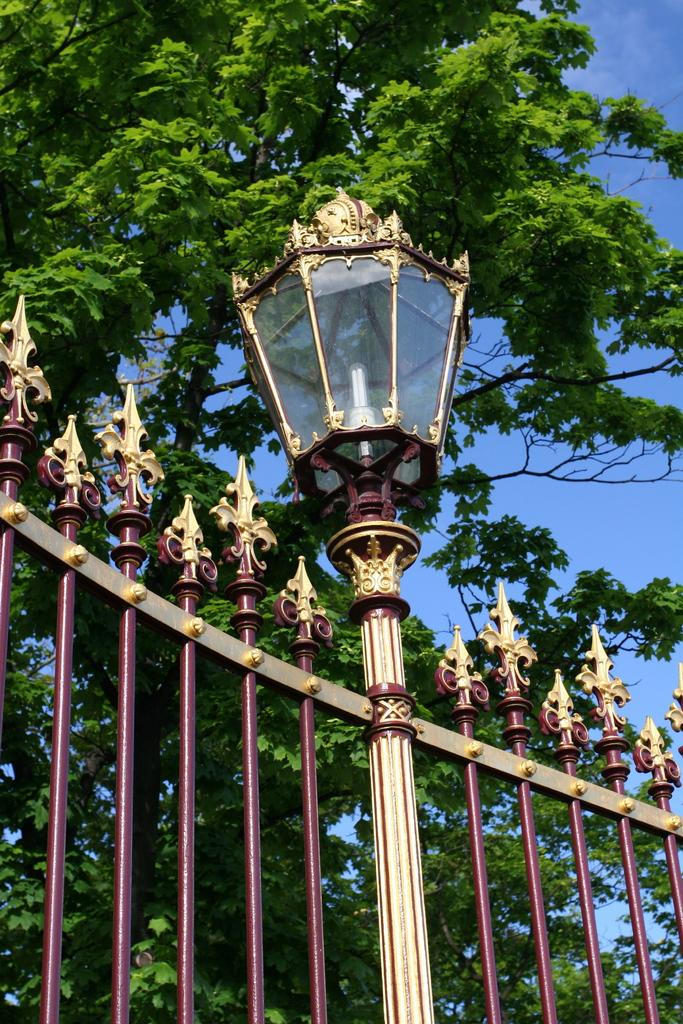What is present in the image that serves as a barrier or divider? There is a fence in the image. Is there any additional feature attached to the fence? Yes, a light is attached to the fence. What can be seen in the background of the image? There is a tree and the sky visible in the background of the image. What type of mint is being used to create harmony in the image? There is no mint or reference to harmony in the image; it features a fence with a light and a background with a tree and the sky. 